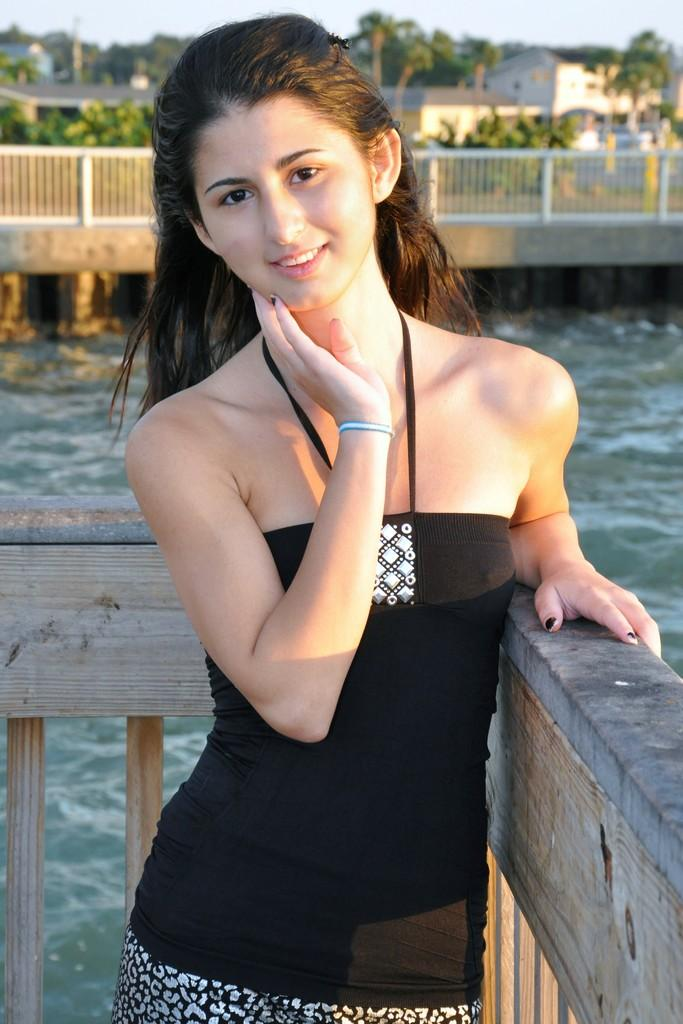What is the woman doing in the image? The woman is standing and smiling in the image. What can be seen above the water in the image? There is a bridge above the water in the image. What type of vegetation is present in the image? There are trees in the image. What type of structures can be seen in the image? There are buildings in the image. What type of barrier is present in the image? There is a fence in the image. What is visible in the sky in the image? The sky is visible in the image. What type of berry is the woman eating for breakfast with her partner in the image? There is no berry, breakfast, breakfast, or partner present in the image. 